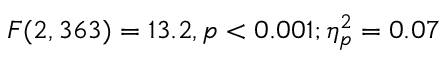Convert formula to latex. <formula><loc_0><loc_0><loc_500><loc_500>F ( 2 , 3 6 3 ) = 1 3 . 2 , p < 0 . 0 0 1 ; \eta _ { p } ^ { 2 } = 0 . 0 7</formula> 